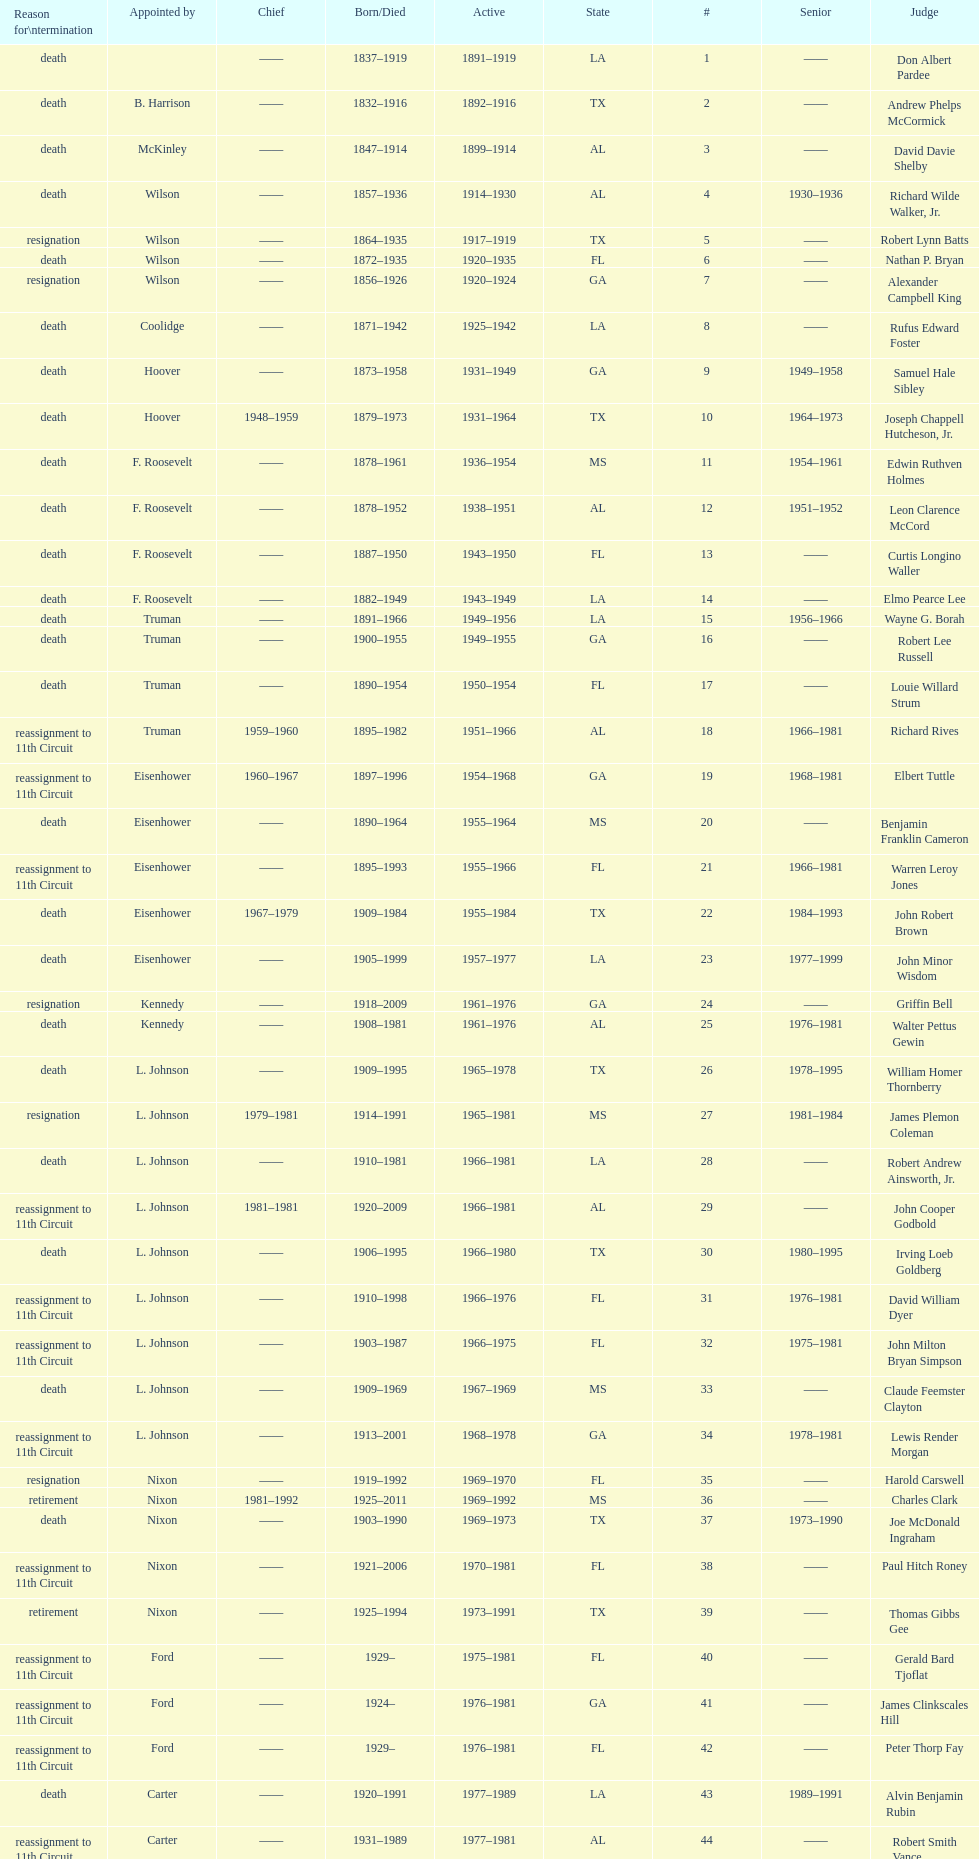Who was the next judge to resign after alexander campbell king? Griffin Bell. 